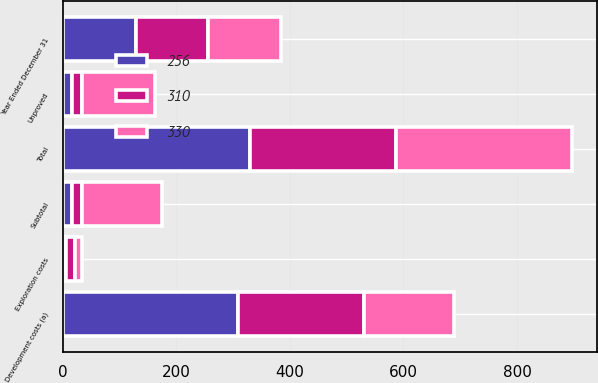Convert chart. <chart><loc_0><loc_0><loc_500><loc_500><stacked_bar_chart><ecel><fcel>Year Ended December 31<fcel>Unproved<fcel>Subtotal<fcel>Exploration costs<fcel>Development costs (a)<fcel>Total<nl><fcel>310<fcel>128<fcel>18<fcel>18<fcel>16<fcel>222<fcel>256<nl><fcel>256<fcel>128<fcel>16<fcel>16<fcel>6<fcel>308<fcel>330<nl><fcel>330<fcel>128<fcel>128<fcel>140<fcel>11<fcel>159<fcel>310<nl></chart> 